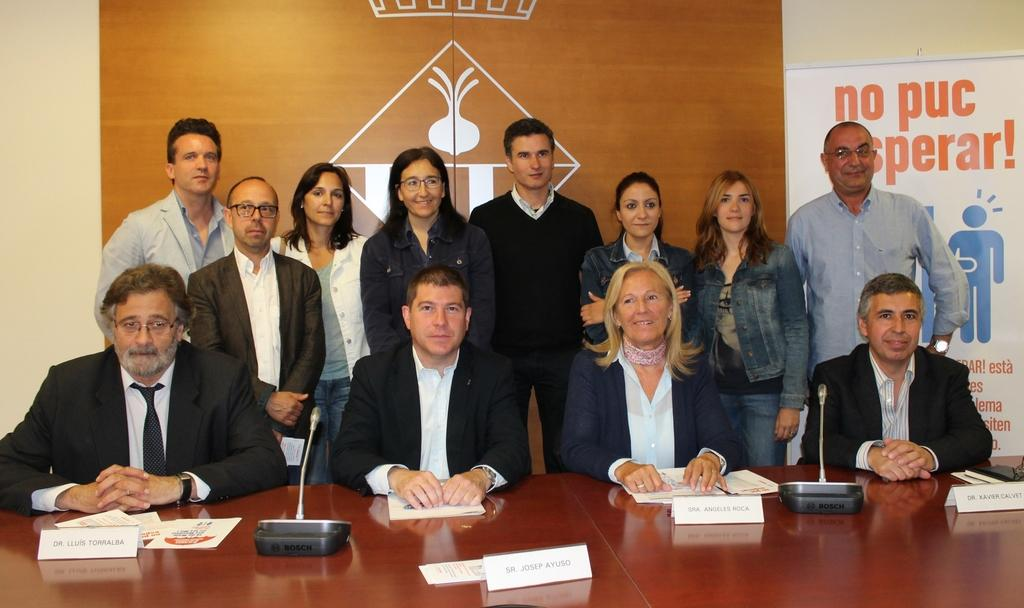How many people are sitting in the image? There are four persons sitting in the image. What objects are on the table in front of the sitting persons? There are microphones, papers, and name plates on the table. Can you describe the people standing in the image? There is a group of people standing in the image, and they are smiling. What else can be seen in the image besides the people? There are boards visible in the image. Where is the jail located in the image? There is no jail present in the image. Can you tell me how many monkeys are visible in the image? There are no monkeys present in the image. 